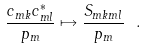Convert formula to latex. <formula><loc_0><loc_0><loc_500><loc_500>\frac { c _ { m k } c ^ { * } _ { m l } } { p _ { m } } \mapsto \frac { S _ { m k m l } } { p _ { m } } \ .</formula> 